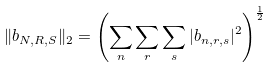<formula> <loc_0><loc_0><loc_500><loc_500>\| b _ { N , R , S } \| _ { 2 } = \left ( \sum _ { n } \sum _ { r } \sum _ { s } | b _ { n , r , s } | ^ { 2 } \right ) ^ { \frac { 1 } { 2 } }</formula> 